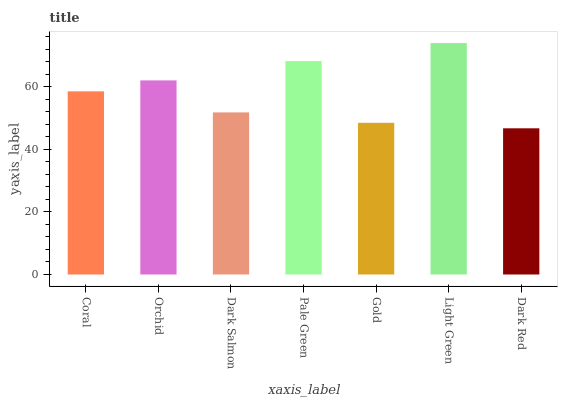Is Dark Red the minimum?
Answer yes or no. Yes. Is Light Green the maximum?
Answer yes or no. Yes. Is Orchid the minimum?
Answer yes or no. No. Is Orchid the maximum?
Answer yes or no. No. Is Orchid greater than Coral?
Answer yes or no. Yes. Is Coral less than Orchid?
Answer yes or no. Yes. Is Coral greater than Orchid?
Answer yes or no. No. Is Orchid less than Coral?
Answer yes or no. No. Is Coral the high median?
Answer yes or no. Yes. Is Coral the low median?
Answer yes or no. Yes. Is Orchid the high median?
Answer yes or no. No. Is Dark Red the low median?
Answer yes or no. No. 